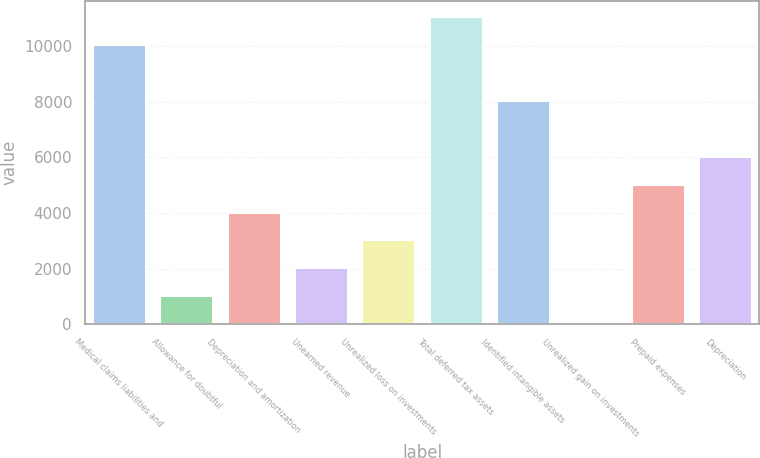Convert chart. <chart><loc_0><loc_0><loc_500><loc_500><bar_chart><fcel>Medical claims liabilities and<fcel>Allowance for doubtful<fcel>Depreciation and amortization<fcel>Unearned revenue<fcel>Unrealized loss on investments<fcel>Total deferred tax assets<fcel>Identified intangible assets<fcel>Unrealized gain on investments<fcel>Prepaid expenses<fcel>Depreciation<nl><fcel>10069<fcel>1043.8<fcel>4052.2<fcel>2046.6<fcel>3049.4<fcel>11071.8<fcel>8063.4<fcel>41<fcel>5055<fcel>6057.8<nl></chart> 